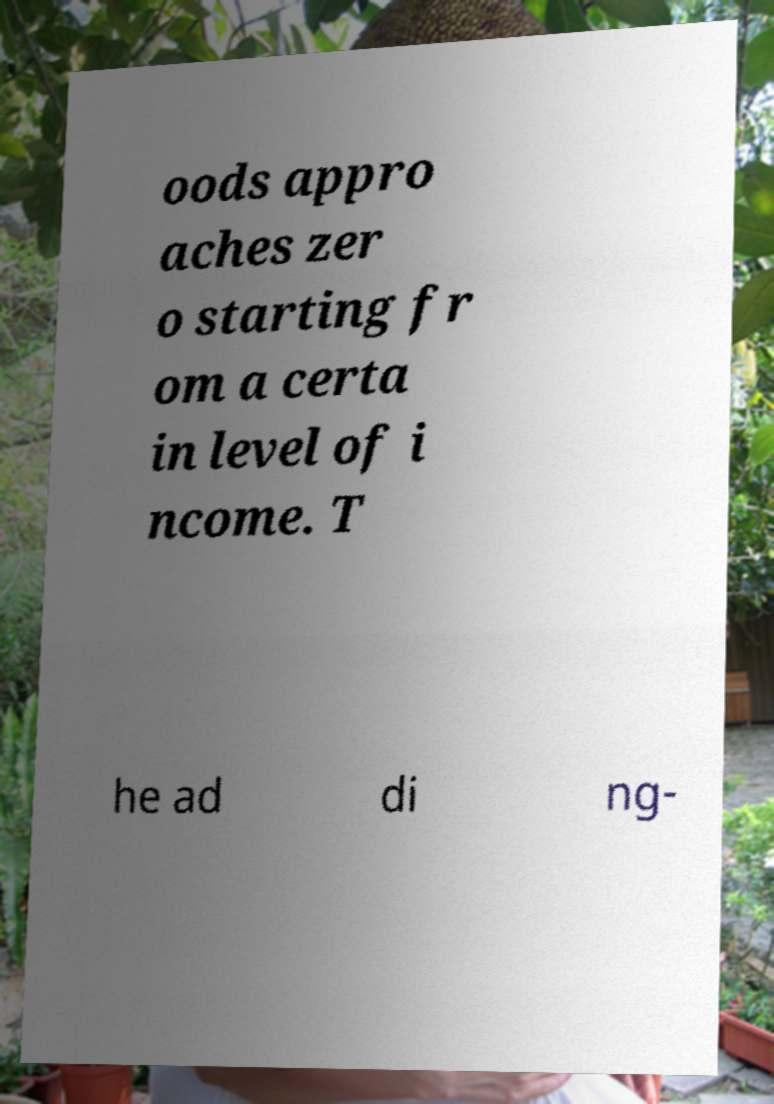What messages or text are displayed in this image? I need them in a readable, typed format. oods appro aches zer o starting fr om a certa in level of i ncome. T he ad di ng- 